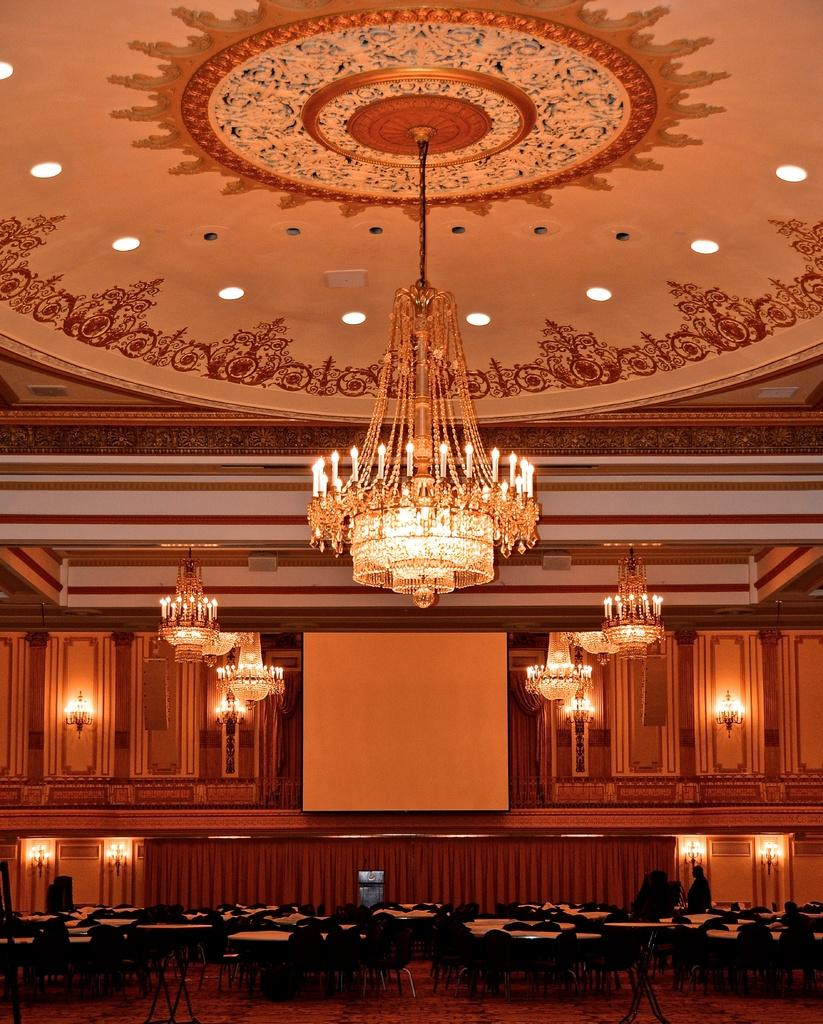What type of furniture is present in the image? There are chairs and tables in the image. What objects provide illumination in the image? There are lamps in the image. Where are the lamps positioned in the image? The lamps are attached to the roof. Can you see any trucks driving through a stream in the image? There are no trucks or streams present in the image. 